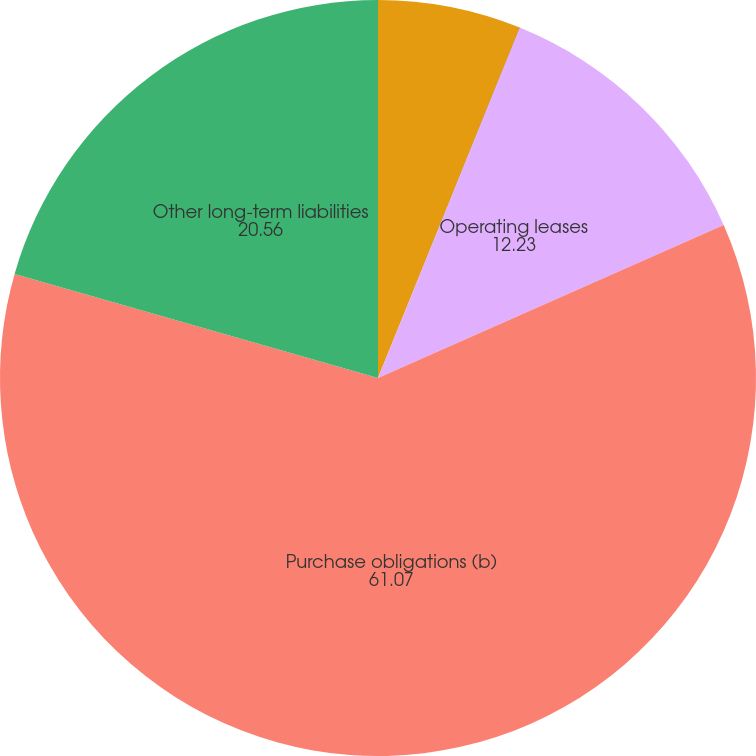Convert chart. <chart><loc_0><loc_0><loc_500><loc_500><pie_chart><fcel>Long-term debt (a)<fcel>Capital lease obligations<fcel>Operating leases<fcel>Purchase obligations (b)<fcel>Other long-term liabilities<nl><fcel>6.12%<fcel>0.02%<fcel>12.23%<fcel>61.07%<fcel>20.56%<nl></chart> 